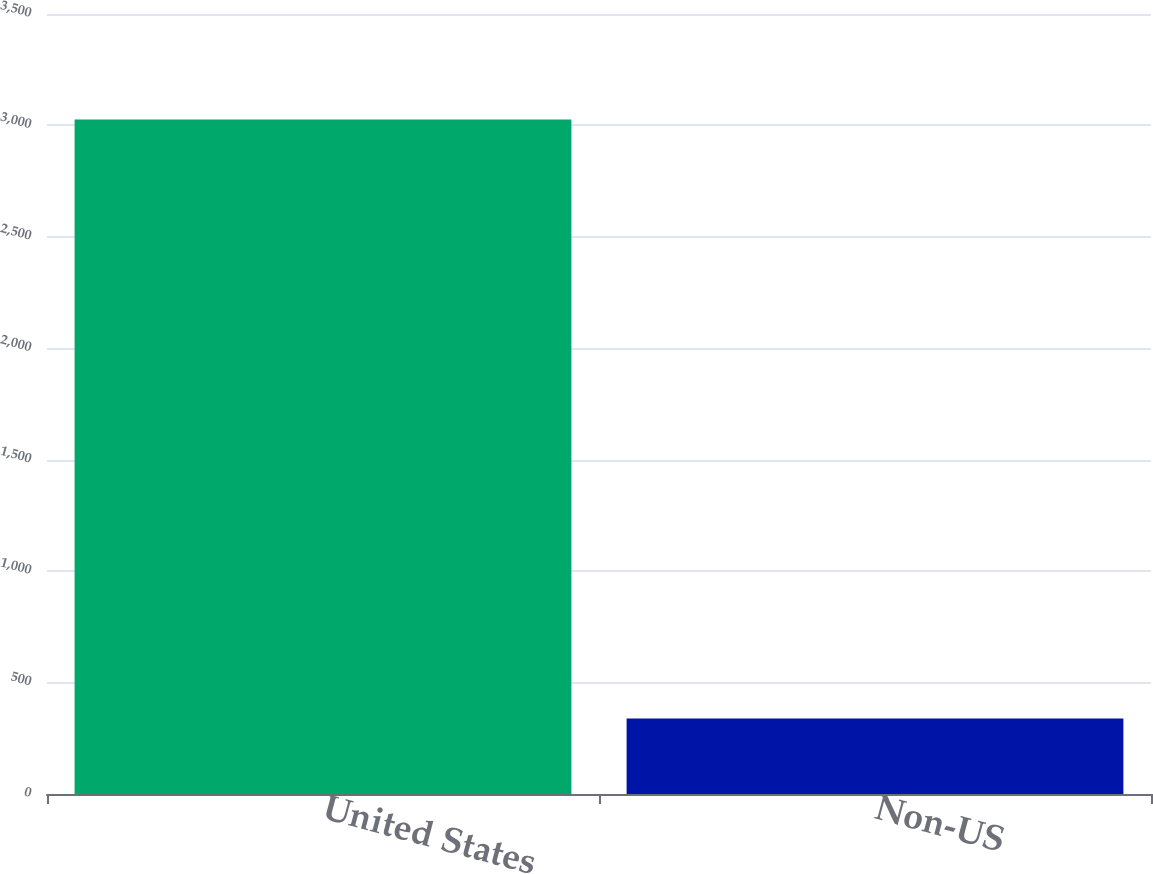<chart> <loc_0><loc_0><loc_500><loc_500><bar_chart><fcel>United States<fcel>Non-US<nl><fcel>3027<fcel>339<nl></chart> 